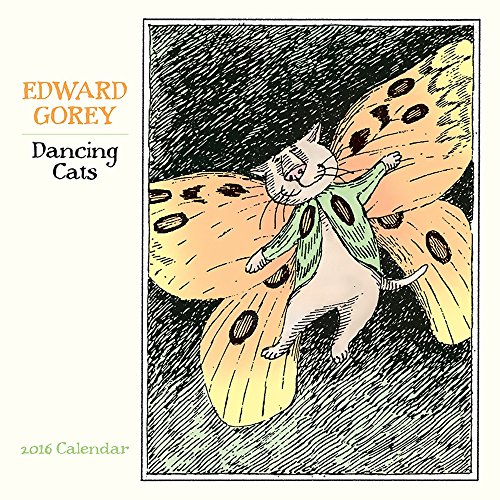What is the title of this book? The book's title is 'Dancing Cats 2016 Calendar', which features charming illustrations of feline figures in mid-dance, guaranteed to entertain viewers throughout the year. 